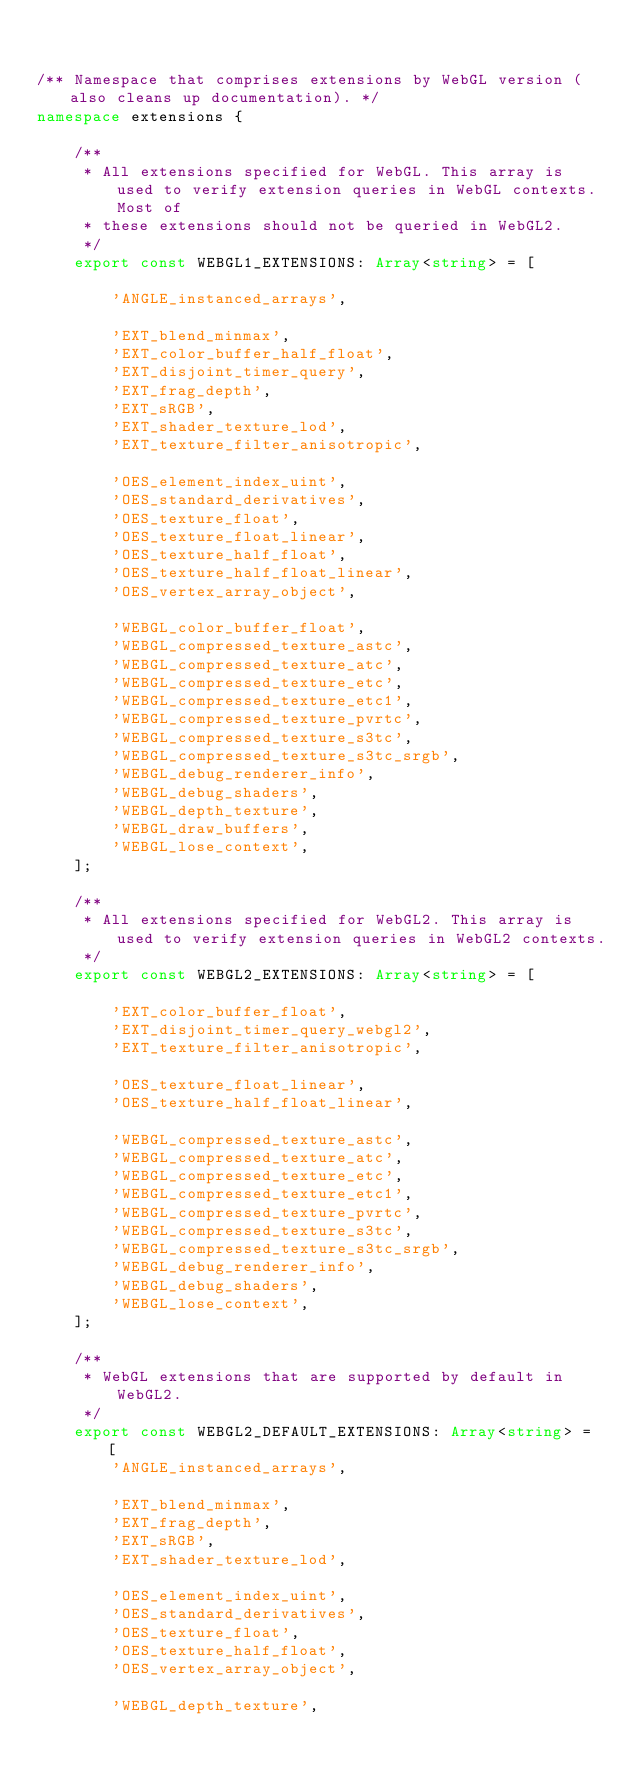Convert code to text. <code><loc_0><loc_0><loc_500><loc_500><_TypeScript_>

/** Namespace that comprises extensions by WebGL version (also cleans up documentation). */
namespace extensions {

    /**
     * All extensions specified for WebGL. This array is used to verify extension queries in WebGL contexts. Most of
     * these extensions should not be queried in WebGL2.
     */
    export const WEBGL1_EXTENSIONS: Array<string> = [

        'ANGLE_instanced_arrays',

        'EXT_blend_minmax',
        'EXT_color_buffer_half_float',
        'EXT_disjoint_timer_query',
        'EXT_frag_depth',
        'EXT_sRGB',
        'EXT_shader_texture_lod',
        'EXT_texture_filter_anisotropic',

        'OES_element_index_uint',
        'OES_standard_derivatives',
        'OES_texture_float',
        'OES_texture_float_linear',
        'OES_texture_half_float',
        'OES_texture_half_float_linear',
        'OES_vertex_array_object',

        'WEBGL_color_buffer_float',
        'WEBGL_compressed_texture_astc',
        'WEBGL_compressed_texture_atc',
        'WEBGL_compressed_texture_etc',
        'WEBGL_compressed_texture_etc1',
        'WEBGL_compressed_texture_pvrtc',
        'WEBGL_compressed_texture_s3tc',
        'WEBGL_compressed_texture_s3tc_srgb',
        'WEBGL_debug_renderer_info',
        'WEBGL_debug_shaders',
        'WEBGL_depth_texture',
        'WEBGL_draw_buffers',
        'WEBGL_lose_context',
    ];

    /**
     * All extensions specified for WebGL2. This array is used to verify extension queries in WebGL2 contexts.
     */
    export const WEBGL2_EXTENSIONS: Array<string> = [

        'EXT_color_buffer_float',
        'EXT_disjoint_timer_query_webgl2',
        'EXT_texture_filter_anisotropic',

        'OES_texture_float_linear',
        'OES_texture_half_float_linear',

        'WEBGL_compressed_texture_astc',
        'WEBGL_compressed_texture_atc',
        'WEBGL_compressed_texture_etc',
        'WEBGL_compressed_texture_etc1',
        'WEBGL_compressed_texture_pvrtc',
        'WEBGL_compressed_texture_s3tc',
        'WEBGL_compressed_texture_s3tc_srgb',
        'WEBGL_debug_renderer_info',
        'WEBGL_debug_shaders',
        'WEBGL_lose_context',
    ];

    /**
     * WebGL extensions that are supported by default in WebGL2.
     */
    export const WEBGL2_DEFAULT_EXTENSIONS: Array<string> = [
        'ANGLE_instanced_arrays',

        'EXT_blend_minmax',
        'EXT_frag_depth',
        'EXT_sRGB',
        'EXT_shader_texture_lod',

        'OES_element_index_uint',
        'OES_standard_derivatives',
        'OES_texture_float',
        'OES_texture_half_float',
        'OES_vertex_array_object',

        'WEBGL_depth_texture',</code> 